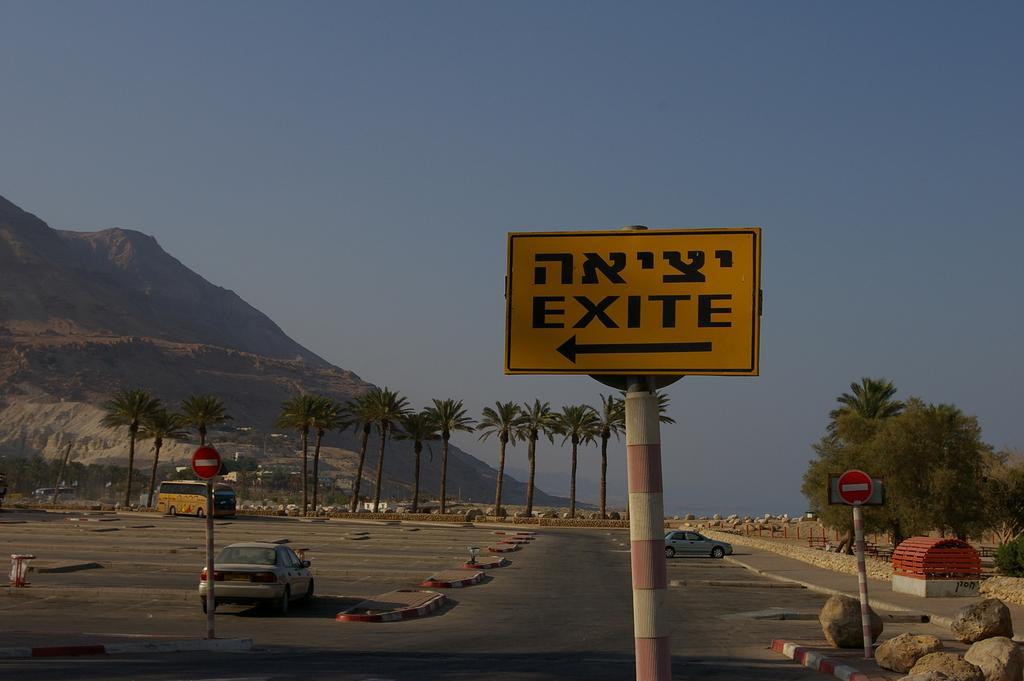How would you summarize this image in a sentence or two? In this image I can see vehicles on the road. Here I can see sign boards, rocks, a mountain, trees and other objects on the ground. In the background I can see the sky. 